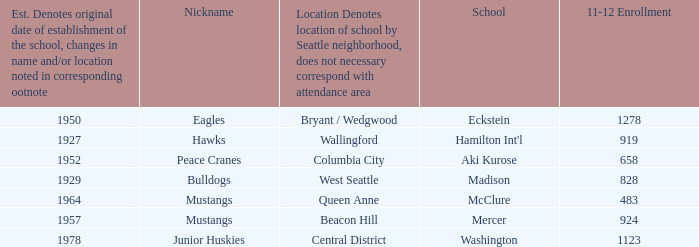Name the location for school eckstein Bryant / Wedgwood. 